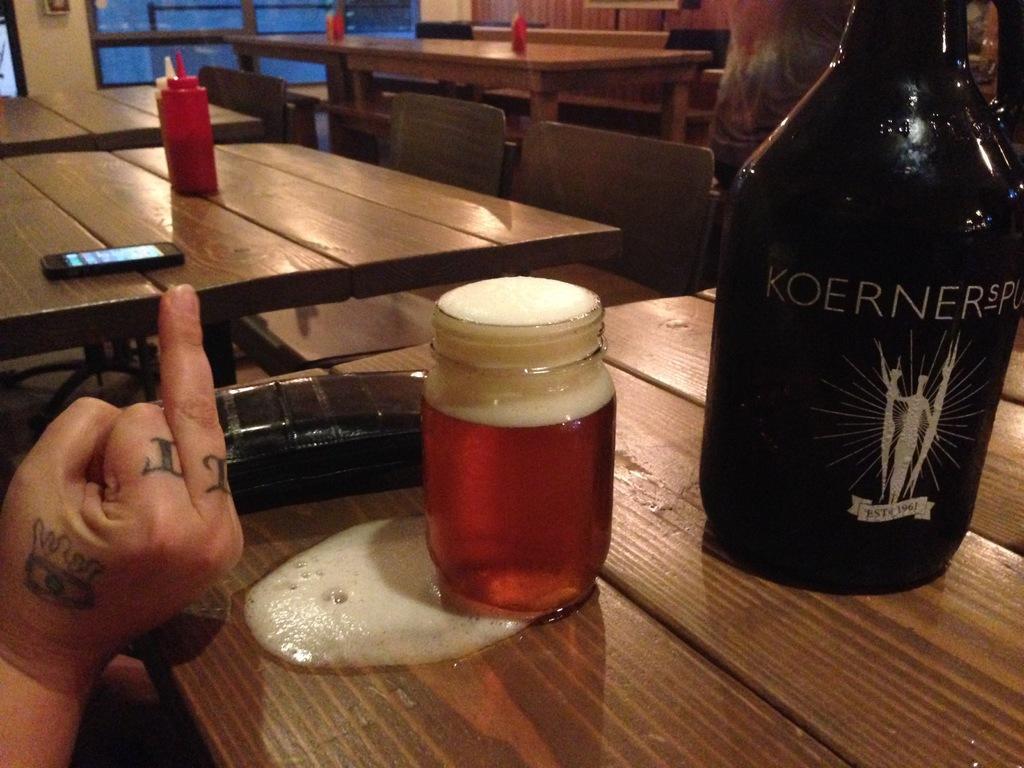Describe this image in one or two sentences. In the image there are tables, on tables we can see bottle,glass bottle on which it is labelled as KOERNER,jar,mobile. On left side we can also see a hand, in background there is a window which is closed and a wall which is in white color. 